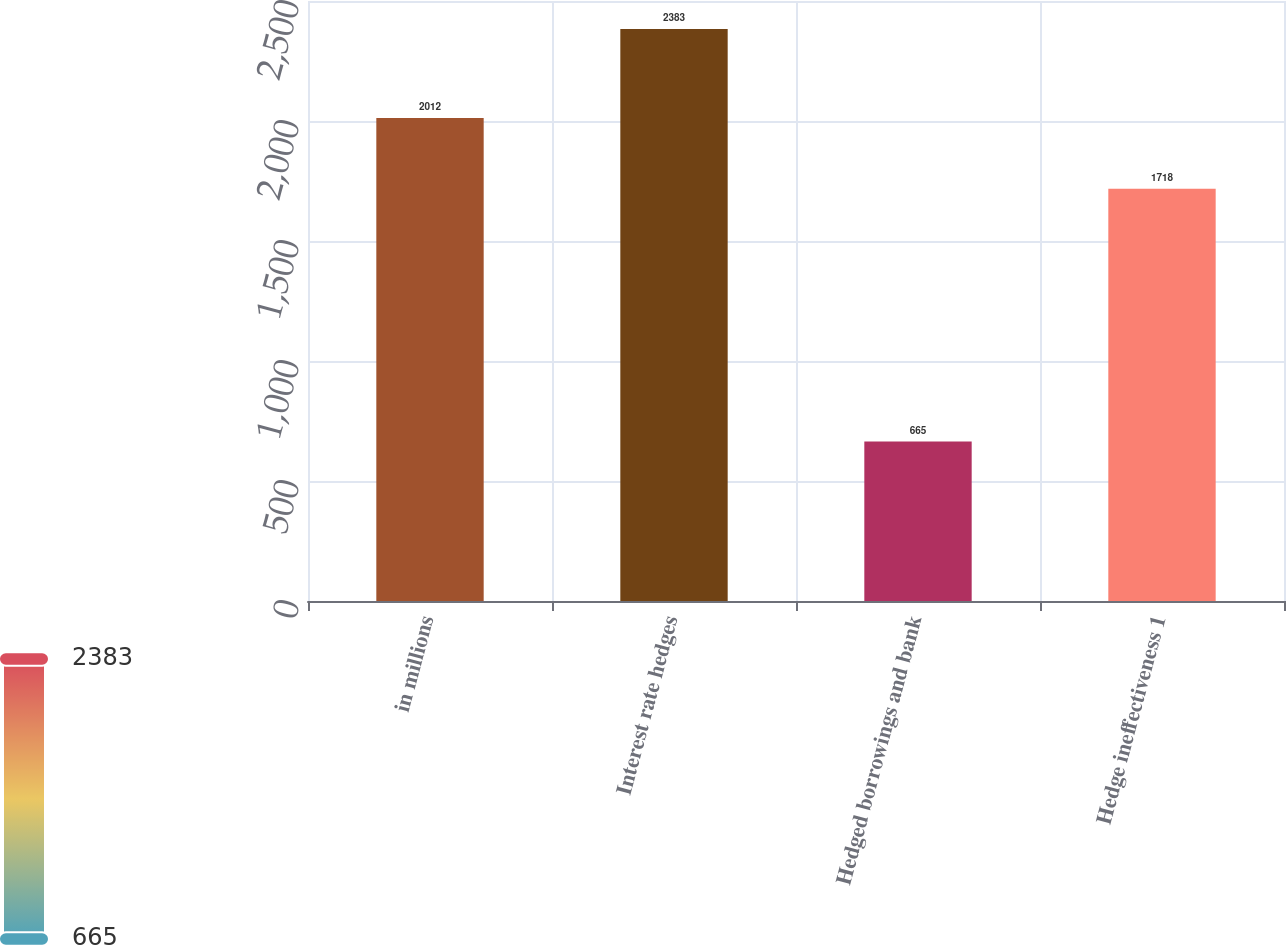Convert chart. <chart><loc_0><loc_0><loc_500><loc_500><bar_chart><fcel>in millions<fcel>Interest rate hedges<fcel>Hedged borrowings and bank<fcel>Hedge ineffectiveness 1<nl><fcel>2012<fcel>2383<fcel>665<fcel>1718<nl></chart> 